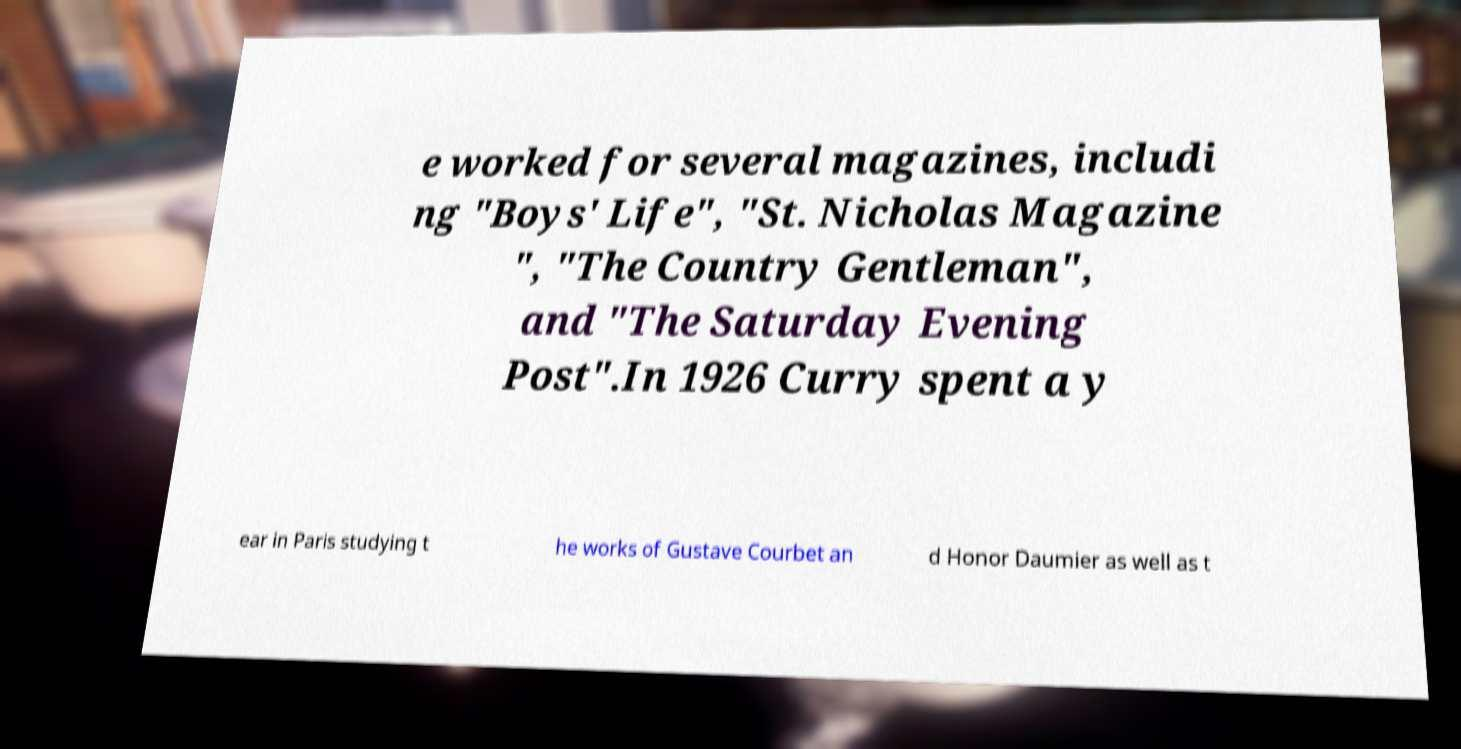Could you extract and type out the text from this image? e worked for several magazines, includi ng "Boys' Life", "St. Nicholas Magazine ", "The Country Gentleman", and "The Saturday Evening Post".In 1926 Curry spent a y ear in Paris studying t he works of Gustave Courbet an d Honor Daumier as well as t 